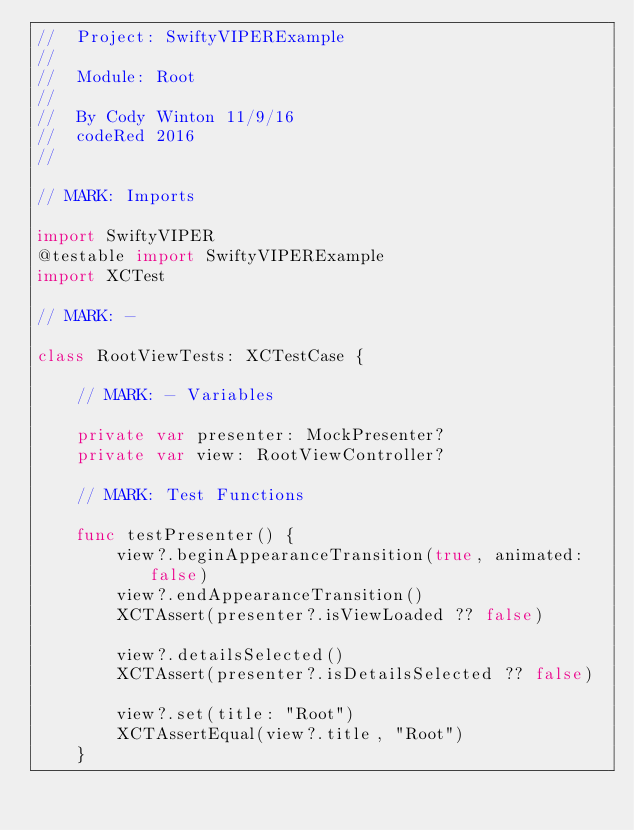<code> <loc_0><loc_0><loc_500><loc_500><_Swift_>//  Project: SwiftyVIPERExample
//
//  Module: Root
//
//  By Cody Winton 11/9/16
//  codeRed 2016
//

// MARK: Imports

import SwiftyVIPER
@testable import SwiftyVIPERExample
import XCTest

// MARK: -

class RootViewTests: XCTestCase {

	// MARK: - Variables

	private var presenter: MockPresenter?
	private var view: RootViewController?

	// MARK: Test Functions

	func testPresenter() {
		view?.beginAppearanceTransition(true, animated: false)
		view?.endAppearanceTransition()
		XCTAssert(presenter?.isViewLoaded ?? false)

		view?.detailsSelected()
		XCTAssert(presenter?.isDetailsSelected ?? false)

		view?.set(title: "Root")
		XCTAssertEqual(view?.title, "Root")
	}
</code> 